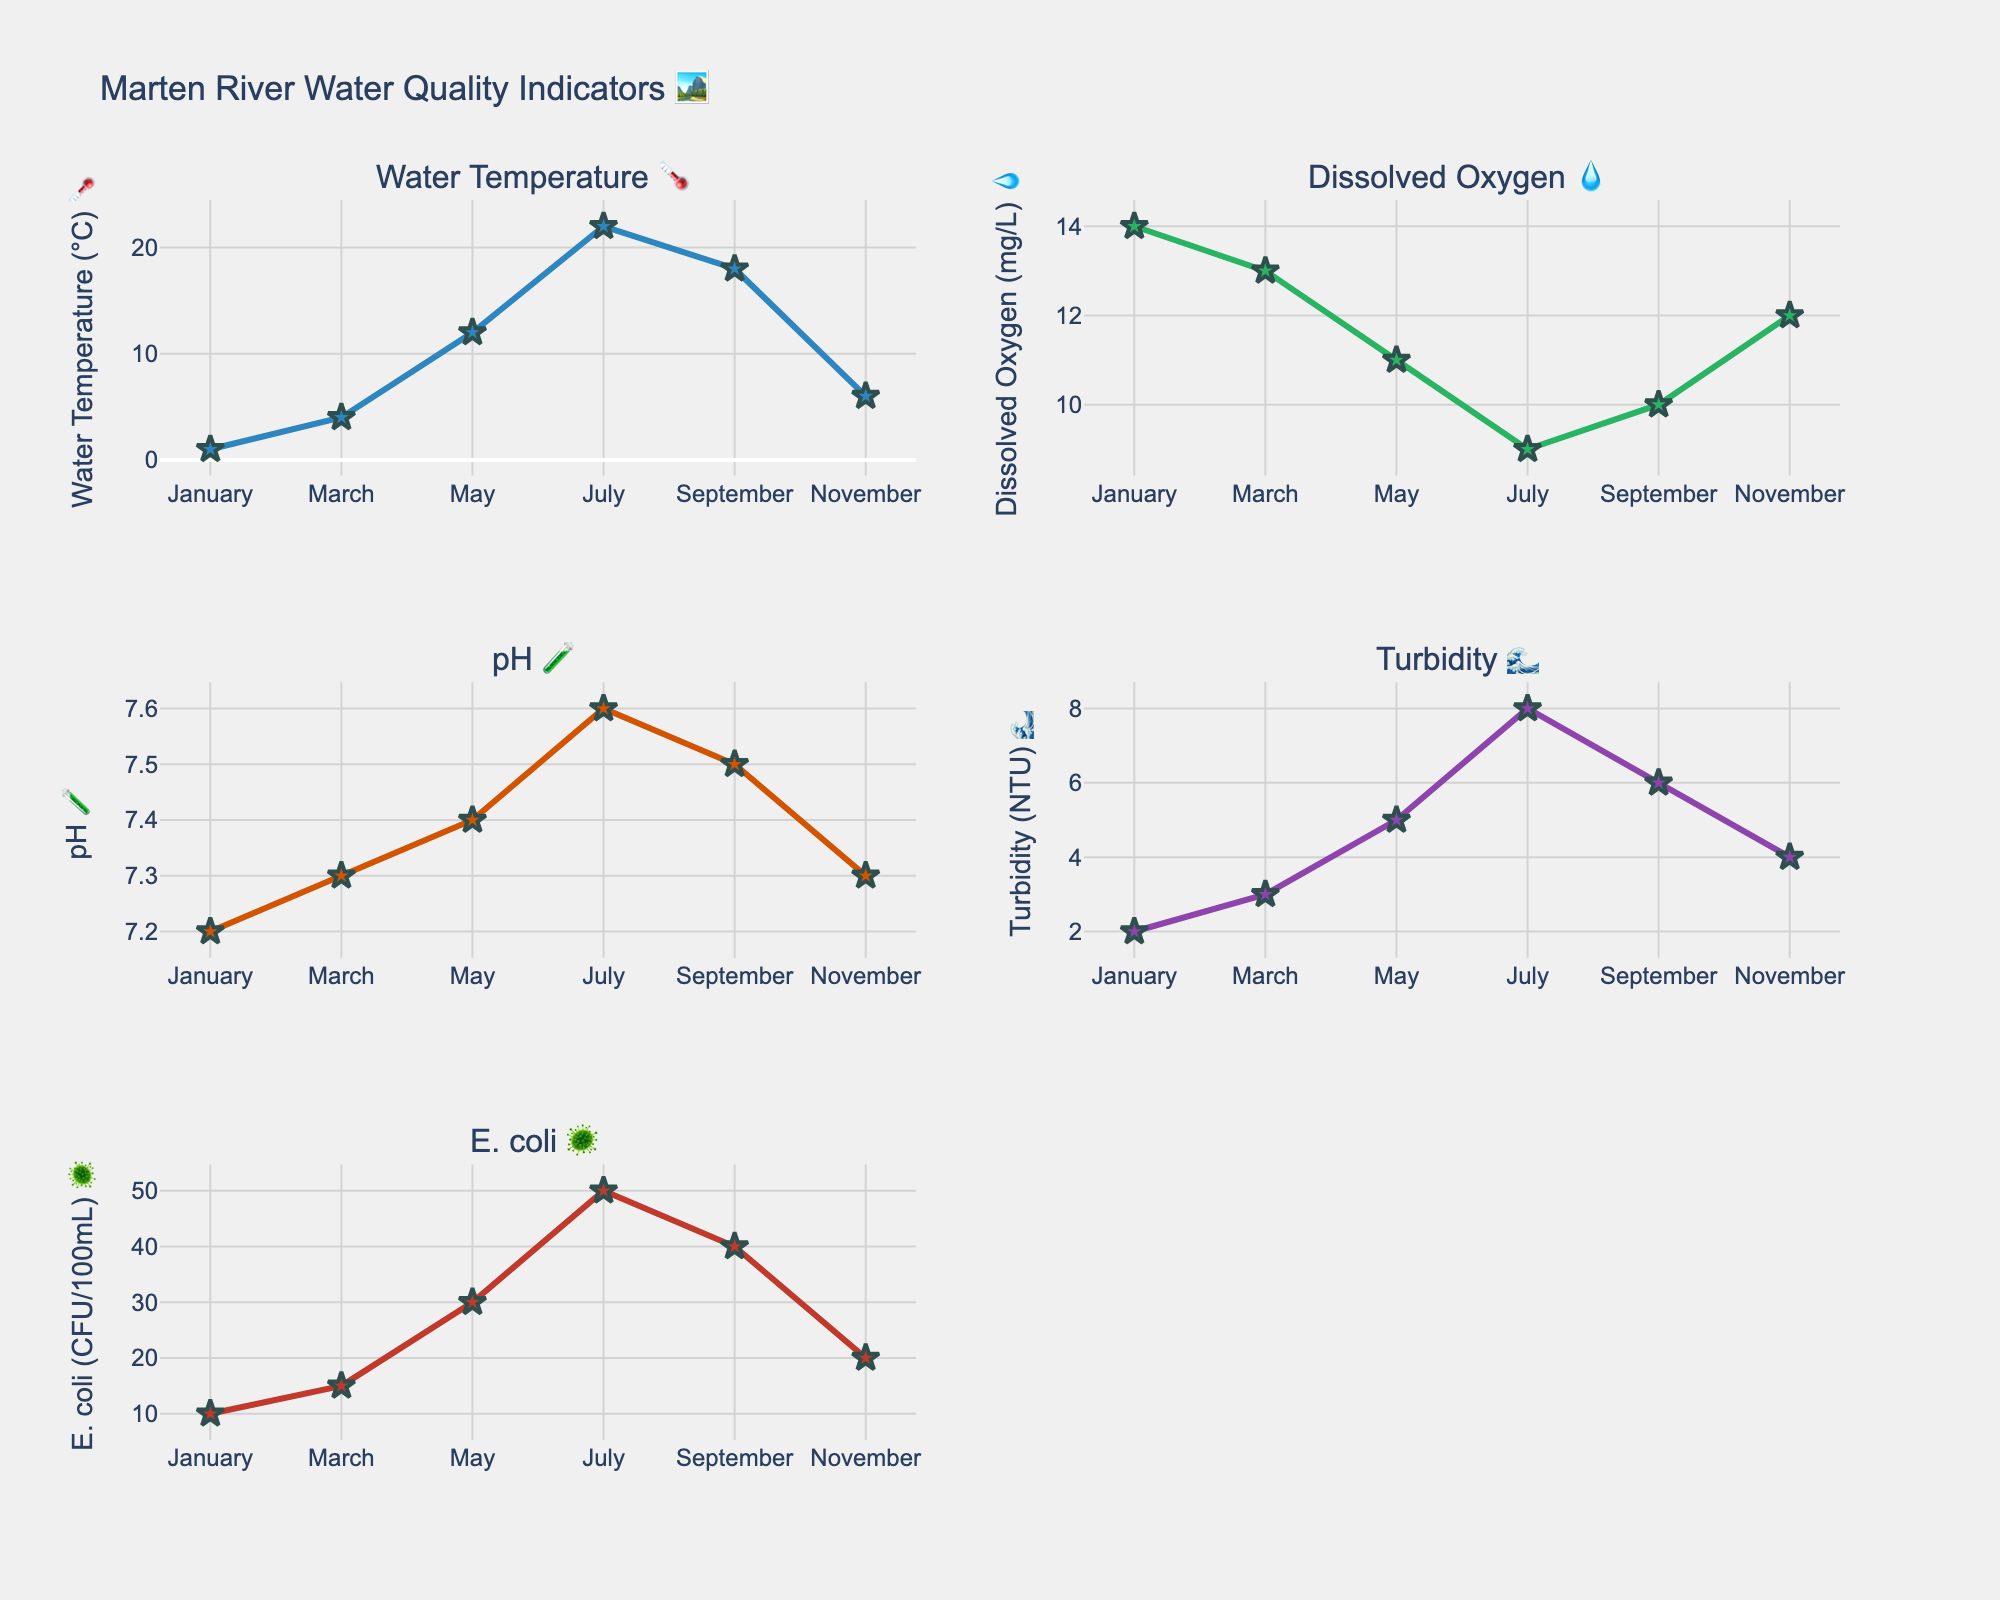What is the highest water temperature recorded in the Marten River? 🌡️ From the water temperature subplot, the highest value on the y-axis is in July at 22°C.
Answer: 22°C In which month is the level of dissolved oxygen the lowest? 💧 By observing the dissolved oxygen subplot, the lowest dissolved oxygen level is in July with a value of 9 mg/L.
Answer: July What is the average pH level throughout the year? 🧪 Look at the y-values of the pH subplot (7.2, 7.3, 7.4, 7.6, 7.5, 7.3). Sum these values and divide by the total number of months (6): (7.2 + 7.3 + 7.4 + 7.6 + 7.5 + 7.3) / 6 = 7.38.
Answer: 7.38 Which month has the highest turbidity level? 🌊 From the turbidity subplot, the highest y-value is in July with a value of 8 NTU.
Answer: July How does the E. coli count change from January to July? 🦠 In the E. coli subplot, January's value is 10 CFU/100mL and July's value is 50 CFU/100mL. The change is 50 - 10 = 40 CFU/100mL.
Answer: Increases by 40 CFU/100mL Which water quality parameter shows the most significant decrease between May and July? Observe each subplot and the corresponding values for May and July. Water Temperature: 12°C to 22°C (+10°C), Dissolved Oxygen: 11 mg/L to 9 mg/L (-2 mg/L), pH: 7.4 to 7.6 (+0.2), Turbidity: 5 NTU to 8 NTU (+3 NTU), E. coli: 30 CFU/100mL to 50 CFU/100mL (+20 CFU/100mL). Dissolved Oxygen decreases by 2 mg/L.
Answer: Dissolved Oxygen Compare the water temperature in March and November. Which month is warmer? 🌡️ Check the water temperature subplot. March (4°C) and November (6°C). November is warmer.
Answer: November What is the change in the turbidity level from March to September? 🌊 In the turbidity subplot, March's value is 3 NTU and September's value is 6 NTU. The change is 6 - 3 = 3 NTU.
Answer: Increases by 3 NTU Is there a correlation between water temperature and dissolved oxygen levels throughout the year? 💧🌡️ Comparing the water temperature and dissolved oxygen subplots, as the water temperature increases, the dissolved oxygen level tends to decrease (inverse relationship).
Answer: Inverse correlation 